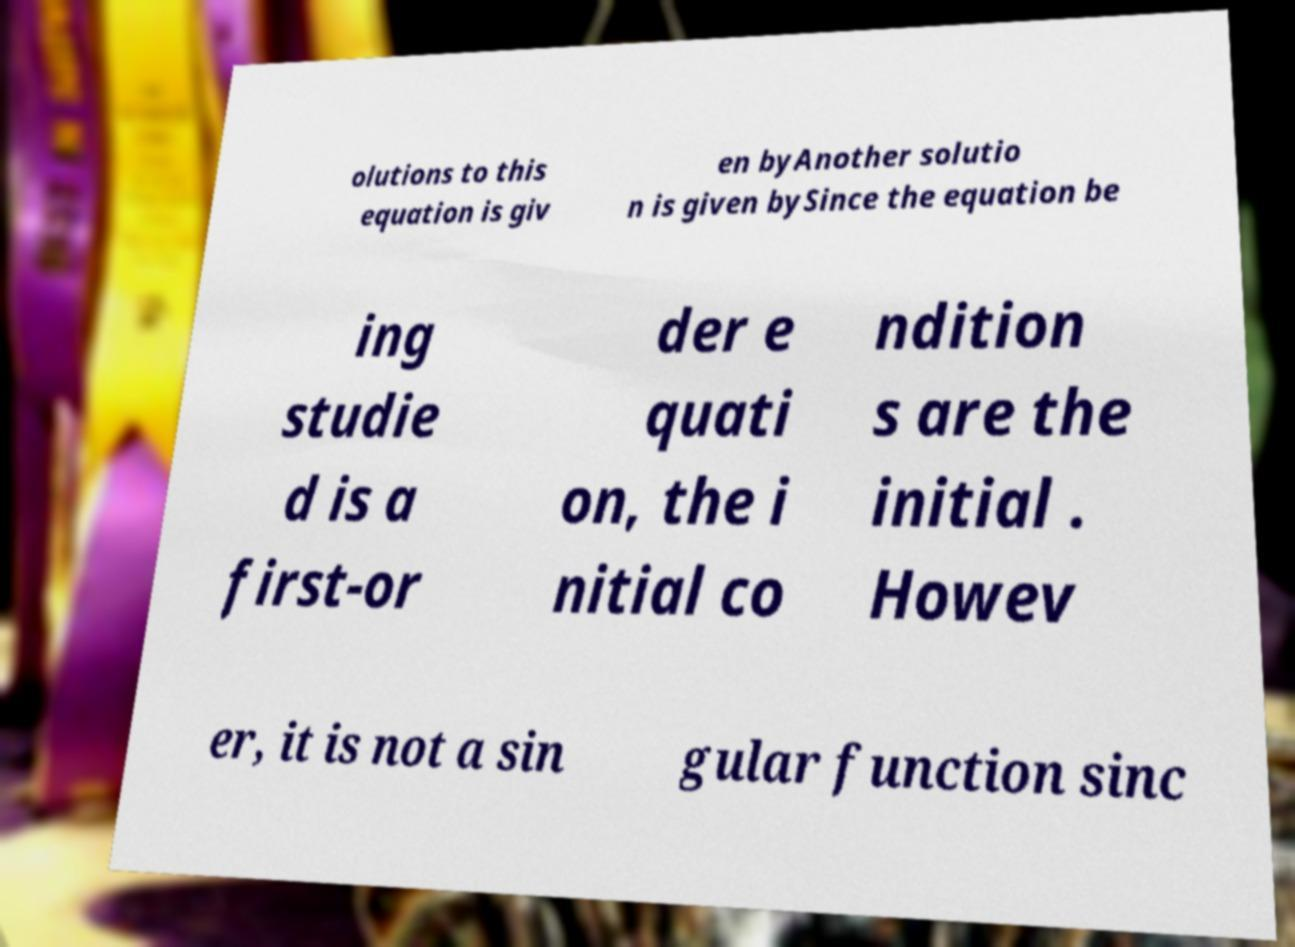Could you extract and type out the text from this image? olutions to this equation is giv en byAnother solutio n is given bySince the equation be ing studie d is a first-or der e quati on, the i nitial co ndition s are the initial . Howev er, it is not a sin gular function sinc 